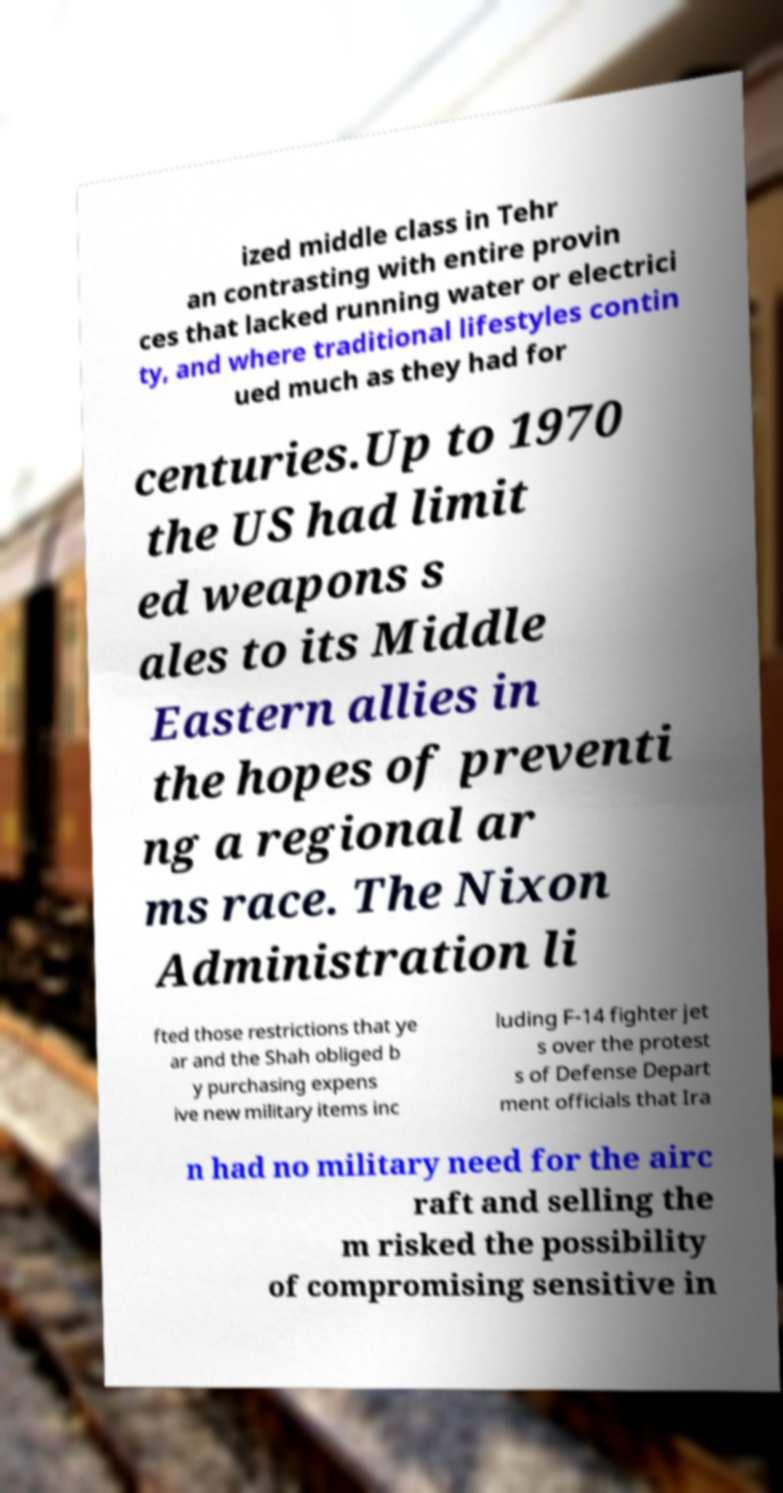Please identify and transcribe the text found in this image. ized middle class in Tehr an contrasting with entire provin ces that lacked running water or electrici ty, and where traditional lifestyles contin ued much as they had for centuries.Up to 1970 the US had limit ed weapons s ales to its Middle Eastern allies in the hopes of preventi ng a regional ar ms race. The Nixon Administration li fted those restrictions that ye ar and the Shah obliged b y purchasing expens ive new military items inc luding F-14 fighter jet s over the protest s of Defense Depart ment officials that Ira n had no military need for the airc raft and selling the m risked the possibility of compromising sensitive in 